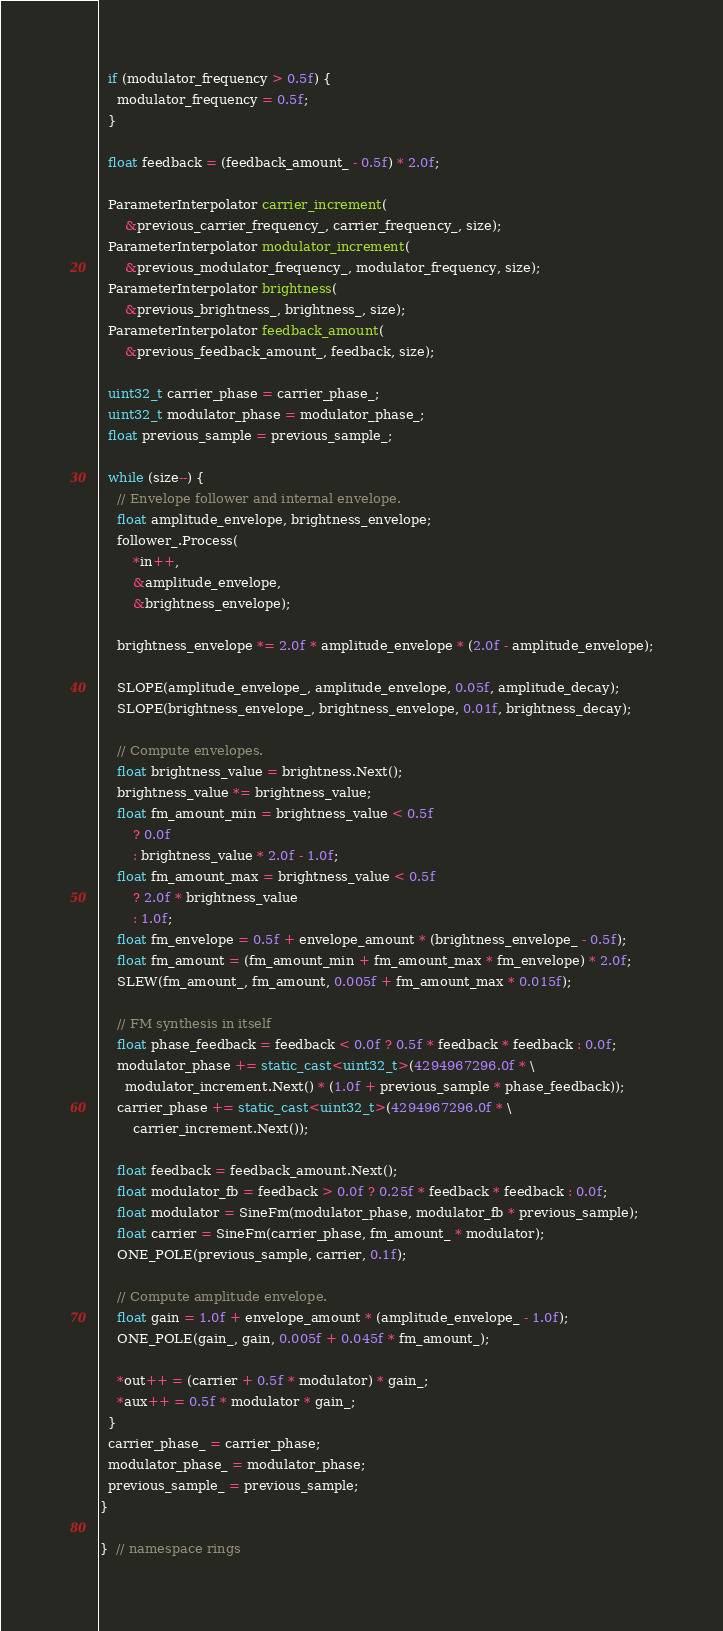<code> <loc_0><loc_0><loc_500><loc_500><_C++_>  if (modulator_frequency > 0.5f) {
    modulator_frequency = 0.5f;
  }
  
  float feedback = (feedback_amount_ - 0.5f) * 2.0f;
  
  ParameterInterpolator carrier_increment(
      &previous_carrier_frequency_, carrier_frequency_, size);
  ParameterInterpolator modulator_increment(
      &previous_modulator_frequency_, modulator_frequency, size);
  ParameterInterpolator brightness(
      &previous_brightness_, brightness_, size);
  ParameterInterpolator feedback_amount(
      &previous_feedback_amount_, feedback, size);

  uint32_t carrier_phase = carrier_phase_;
  uint32_t modulator_phase = modulator_phase_;
  float previous_sample = previous_sample_;
  
  while (size--) {
    // Envelope follower and internal envelope.
    float amplitude_envelope, brightness_envelope;
    follower_.Process(
        *in++,
        &amplitude_envelope,
        &brightness_envelope);
    
    brightness_envelope *= 2.0f * amplitude_envelope * (2.0f - amplitude_envelope);
    
    SLOPE(amplitude_envelope_, amplitude_envelope, 0.05f, amplitude_decay);
    SLOPE(brightness_envelope_, brightness_envelope, 0.01f, brightness_decay);
    
    // Compute envelopes.
    float brightness_value = brightness.Next();
    brightness_value *= brightness_value;
    float fm_amount_min = brightness_value < 0.5f
        ? 0.0f
        : brightness_value * 2.0f - 1.0f;
    float fm_amount_max = brightness_value < 0.5f
        ? 2.0f * brightness_value
        : 1.0f;
    float fm_envelope = 0.5f + envelope_amount * (brightness_envelope_ - 0.5f);
    float fm_amount = (fm_amount_min + fm_amount_max * fm_envelope) * 2.0f;
    SLEW(fm_amount_, fm_amount, 0.005f + fm_amount_max * 0.015f);

    // FM synthesis in itself
    float phase_feedback = feedback < 0.0f ? 0.5f * feedback * feedback : 0.0f;
    modulator_phase += static_cast<uint32_t>(4294967296.0f * \
      modulator_increment.Next() * (1.0f + previous_sample * phase_feedback));
    carrier_phase += static_cast<uint32_t>(4294967296.0f * \
        carrier_increment.Next());

    float feedback = feedback_amount.Next();
    float modulator_fb = feedback > 0.0f ? 0.25f * feedback * feedback : 0.0f;
    float modulator = SineFm(modulator_phase, modulator_fb * previous_sample);
    float carrier = SineFm(carrier_phase, fm_amount_ * modulator);
    ONE_POLE(previous_sample, carrier, 0.1f);

    // Compute amplitude envelope.
    float gain = 1.0f + envelope_amount * (amplitude_envelope_ - 1.0f);
    ONE_POLE(gain_, gain, 0.005f + 0.045f * fm_amount_);
    
    *out++ = (carrier + 0.5f * modulator) * gain_;
    *aux++ = 0.5f * modulator * gain_;
  }
  carrier_phase_ = carrier_phase;
  modulator_phase_ = modulator_phase;
  previous_sample_ = previous_sample;
}

}  // namespace rings
</code> 